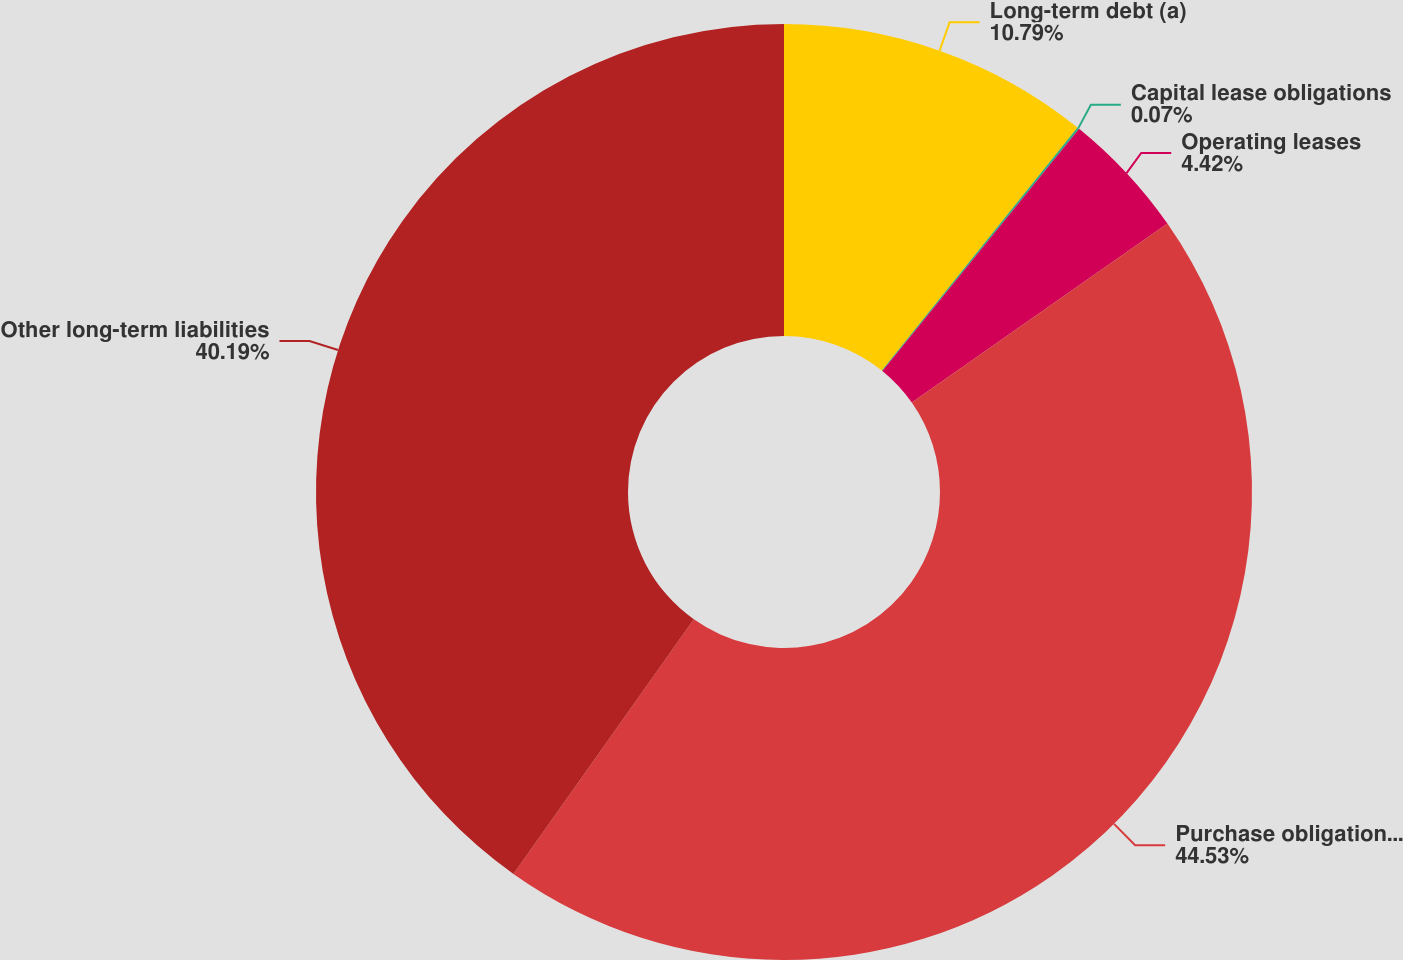Convert chart to OTSL. <chart><loc_0><loc_0><loc_500><loc_500><pie_chart><fcel>Long-term debt (a)<fcel>Capital lease obligations<fcel>Operating leases<fcel>Purchase obligations (b)<fcel>Other long-term liabilities<nl><fcel>10.79%<fcel>0.07%<fcel>4.42%<fcel>44.53%<fcel>40.19%<nl></chart> 